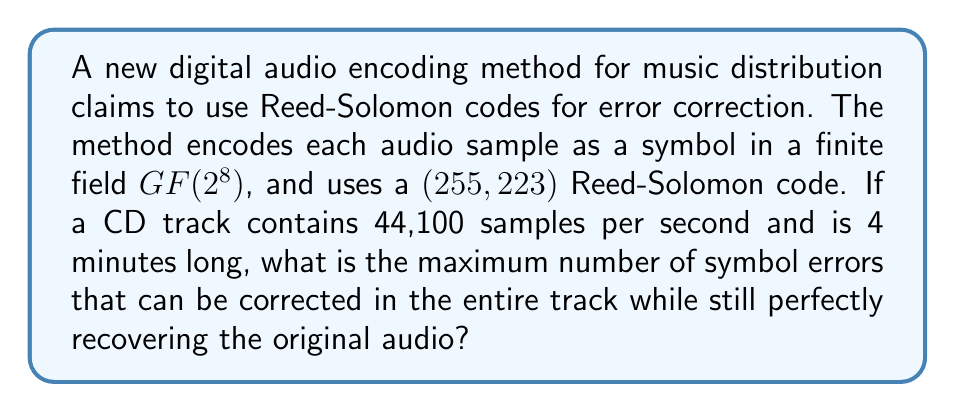Give your solution to this math problem. To solve this problem, we need to follow these steps:

1) First, let's calculate the total number of symbols in the 4-minute track:
   - Samples per second: 44,100
   - Seconds in 4 minutes: 4 * 60 = 240
   - Total samples: 44,100 * 240 = 10,584,000 symbols

2) Now, let's consider the properties of the Reed-Solomon code:
   - It's a $(255, 223)$ code, meaning each codeword has 255 symbols, of which 223 are data symbols.
   - The error-correcting capability of a Reed-Solomon code is given by:
     $t = \lfloor \frac{n-k}{2} \rfloor$
     where $n$ is the codeword length and $k$ is the number of data symbols.

3) Calculate the error-correcting capability:
   $t = \lfloor \frac{255-223}{2} \rfloor = \lfloor 16 \rfloor = 16$

   This means each codeword can correct up to 16 symbol errors.

4) Calculate the number of codewords in the entire track:
   Number of codewords = $\lceil \frac{10,584,000}{223} \rceil = 47,462$

5) Calculate the total number of correctable errors:
   Total correctable errors = 47,462 * 16 = 759,392

Therefore, the maximum number of symbol errors that can be corrected in the entire track while still perfectly recovering the original audio is 759,392.
Answer: 759,392 symbol errors 